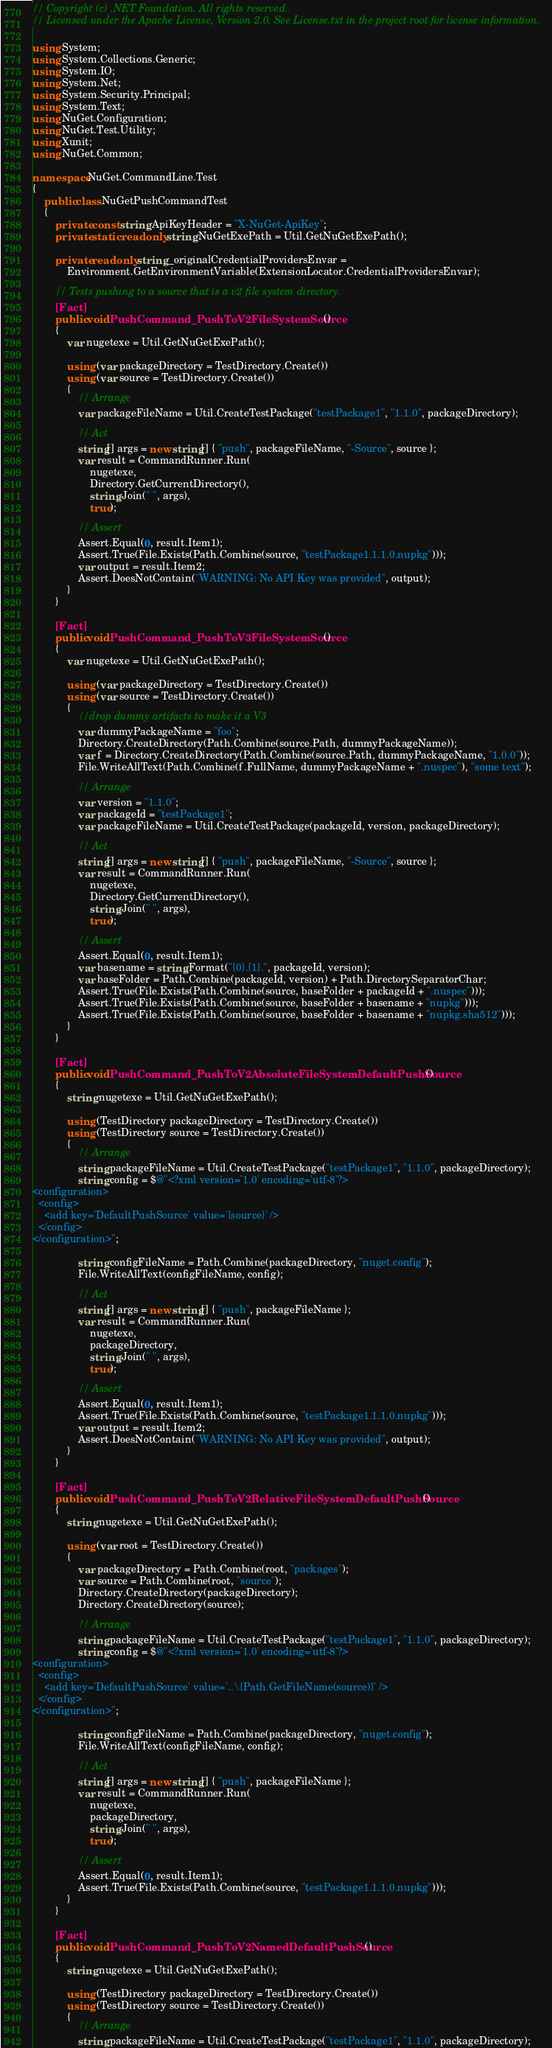Convert code to text. <code><loc_0><loc_0><loc_500><loc_500><_C#_>// Copyright (c) .NET Foundation. All rights reserved.
// Licensed under the Apache License, Version 2.0. See License.txt in the project root for license information.

using System;
using System.Collections.Generic;
using System.IO;
using System.Net;
using System.Security.Principal;
using System.Text;
using NuGet.Configuration;
using NuGet.Test.Utility;
using Xunit;
using NuGet.Common;

namespace NuGet.CommandLine.Test
{
    public class NuGetPushCommandTest
    {
        private const string ApiKeyHeader = "X-NuGet-ApiKey";
        private static readonly string NuGetExePath = Util.GetNuGetExePath();

        private readonly string _originalCredentialProvidersEnvar =
            Environment.GetEnvironmentVariable(ExtensionLocator.CredentialProvidersEnvar);

        // Tests pushing to a source that is a v2 file system directory.
        [Fact]
        public void PushCommand_PushToV2FileSystemSource()
        {
            var nugetexe = Util.GetNuGetExePath();

            using (var packageDirectory = TestDirectory.Create())
            using (var source = TestDirectory.Create())
            {
                // Arrange
                var packageFileName = Util.CreateTestPackage("testPackage1", "1.1.0", packageDirectory);

                // Act
                string[] args = new string[] { "push", packageFileName, "-Source", source };
                var result = CommandRunner.Run(
                    nugetexe,
                    Directory.GetCurrentDirectory(),
                    string.Join(" ", args),
                    true);

                // Assert
                Assert.Equal(0, result.Item1);
                Assert.True(File.Exists(Path.Combine(source, "testPackage1.1.1.0.nupkg")));
                var output = result.Item2;
                Assert.DoesNotContain("WARNING: No API Key was provided", output);
            }
        }

        [Fact]
        public void PushCommand_PushToV3FileSystemSource()
        {
            var nugetexe = Util.GetNuGetExePath();

            using (var packageDirectory = TestDirectory.Create())
            using (var source = TestDirectory.Create())
            {
                //drop dummy artifacts to make it a V3
                var dummyPackageName = "foo";
                Directory.CreateDirectory(Path.Combine(source.Path, dummyPackageName));
                var f = Directory.CreateDirectory(Path.Combine(source.Path, dummyPackageName, "1.0.0"));
                File.WriteAllText(Path.Combine(f.FullName, dummyPackageName + ".nuspec"), "some text");

                // Arrange
                var version = "1.1.0";
                var packageId = "testPackage1";
                var packageFileName = Util.CreateTestPackage(packageId, version, packageDirectory);

                // Act
                string[] args = new string[] { "push", packageFileName, "-Source", source };
                var result = CommandRunner.Run(
                    nugetexe,
                    Directory.GetCurrentDirectory(),
                    string.Join(" ", args),
                    true);

                // Assert
                Assert.Equal(0, result.Item1);
                var basename = string.Format("{0}.{1}.", packageId, version);
                var baseFolder = Path.Combine(packageId, version) + Path.DirectorySeparatorChar;
                Assert.True(File.Exists(Path.Combine(source, baseFolder + packageId + ".nuspec")));
                Assert.True(File.Exists(Path.Combine(source, baseFolder + basename + "nupkg")));
                Assert.True(File.Exists(Path.Combine(source, baseFolder + basename + "nupkg.sha512")));
            }
        }

        [Fact]
        public void PushCommand_PushToV2AbsoluteFileSystemDefaultPushSource()
        {
            string nugetexe = Util.GetNuGetExePath();

            using (TestDirectory packageDirectory = TestDirectory.Create())
            using (TestDirectory source = TestDirectory.Create())
            {
                // Arrange
                string packageFileName = Util.CreateTestPackage("testPackage1", "1.1.0", packageDirectory);
                string config = $@"<?xml version='1.0' encoding='utf-8'?>
<configuration>
  <config>
    <add key='DefaultPushSource' value='{source}' />
  </config>
</configuration>";

                string configFileName = Path.Combine(packageDirectory, "nuget.config");
                File.WriteAllText(configFileName, config);

                // Act
                string[] args = new string[] { "push", packageFileName };
                var result = CommandRunner.Run(
                    nugetexe,
                    packageDirectory,
                    string.Join(" ", args),
                    true);

                // Assert
                Assert.Equal(0, result.Item1);
                Assert.True(File.Exists(Path.Combine(source, "testPackage1.1.1.0.nupkg")));
                var output = result.Item2;
                Assert.DoesNotContain("WARNING: No API Key was provided", output);
            }
        }

        [Fact]
        public void PushCommand_PushToV2RelativeFileSystemDefaultPushSource()
        {
            string nugetexe = Util.GetNuGetExePath();

            using (var root = TestDirectory.Create())
            {
                var packageDirectory = Path.Combine(root, "packages");
                var source = Path.Combine(root, "source");
                Directory.CreateDirectory(packageDirectory);
                Directory.CreateDirectory(source);

                // Arrange
                string packageFileName = Util.CreateTestPackage("testPackage1", "1.1.0", packageDirectory);
                string config = $@"<?xml version='1.0' encoding='utf-8'?>
<configuration>
  <config>
    <add key='DefaultPushSource' value='..\{Path.GetFileName(source)}' />
  </config>
</configuration>";

                string configFileName = Path.Combine(packageDirectory, "nuget.config");
                File.WriteAllText(configFileName, config);

                // Act
                string[] args = new string[] { "push", packageFileName };
                var result = CommandRunner.Run(
                    nugetexe,
                    packageDirectory,
                    string.Join(" ", args),
                    true);

                // Assert
                Assert.Equal(0, result.Item1);
                Assert.True(File.Exists(Path.Combine(source, "testPackage1.1.1.0.nupkg")));
            }
        }

        [Fact]
        public void PushCommand_PushToV2NamedDefaultPushSource()
        {
            string nugetexe = Util.GetNuGetExePath();

            using (TestDirectory packageDirectory = TestDirectory.Create())
            using (TestDirectory source = TestDirectory.Create())
            {
                // Arrange
                string packageFileName = Util.CreateTestPackage("testPackage1", "1.1.0", packageDirectory);</code> 